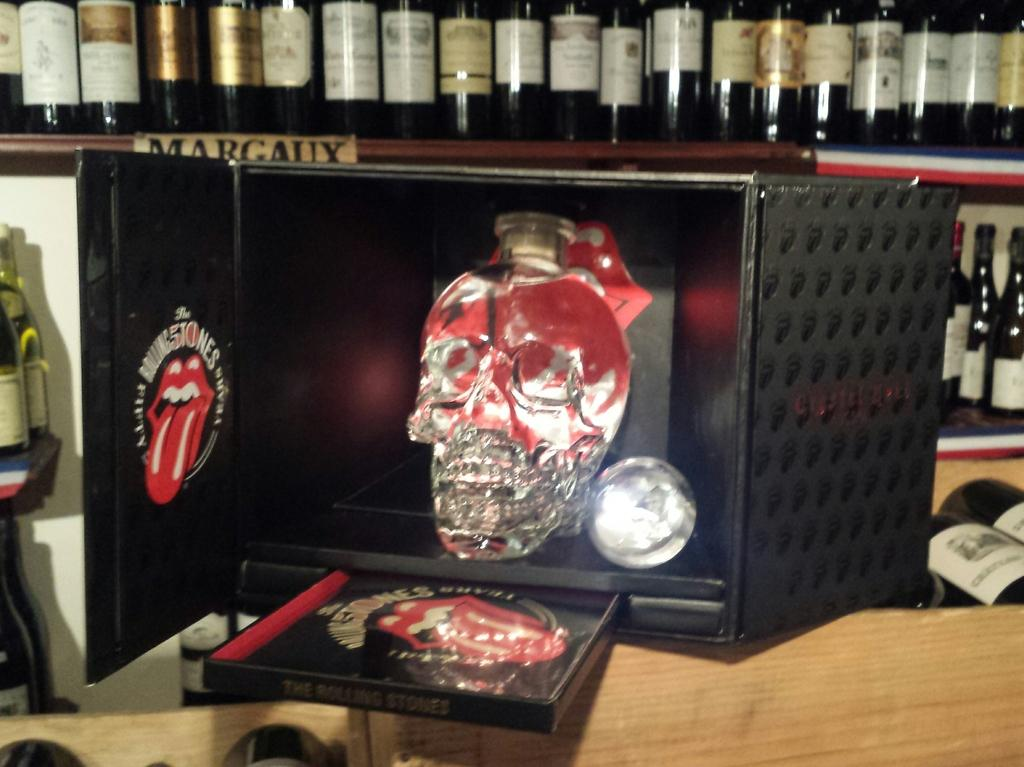What is inside the box in the image? There is a sculpture in a box in the image. What can be seen beside the box in the image? There are bottles in racks beside the box in the image. What type of rhythm is being played by the sculpture in the image? There is no rhythm being played by the sculpture in the image, as it is a static object inside a box. 